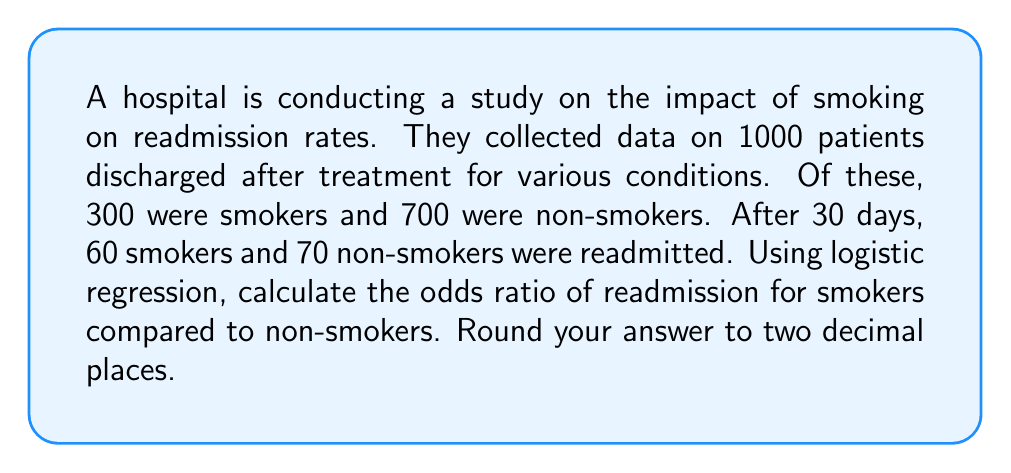Give your solution to this math problem. Let's approach this step-by-step using logistic regression:

1) First, we need to create a 2x2 contingency table:

   | Group     | Readmitted | Not Readmitted | Total |
   |-----------|------------|----------------|-------|
   | Smokers   | 60         | 240            | 300   |
   | Non-smokers| 70         | 630            | 700   |
   | Total     | 130        | 870            | 1000  |

2) The odds ratio (OR) is calculated as:

   $$ OR = \frac{(a/b)}{(c/d)} $$

   Where:
   a = number of exposed cases (readmitted smokers)
   b = number of exposed non-cases (non-readmitted smokers)
   c = number of unexposed cases (readmitted non-smokers)
   d = number of unexposed non-cases (non-readmitted non-smokers)

3) Plugging in our values:

   $$ OR = \frac{(60/240)}{(70/630)} $$

4) Simplify:

   $$ OR = \frac{60 * 630}{240 * 70} = \frac{37800}{16800} $$

5) Calculate:

   $$ OR = 2.25 $$

This means that the odds of readmission for smokers are 2.25 times higher than for non-smokers.
Answer: 2.25 